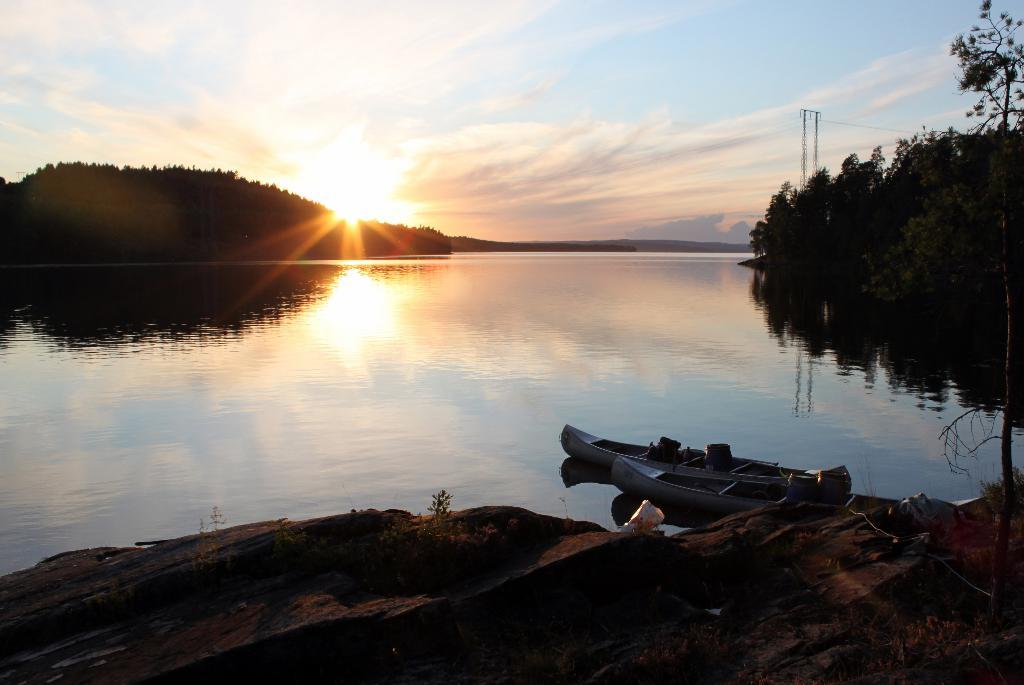What is one of the main elements in the image? There is water in the image. What other objects can be seen in the water? There are boats in the image. What type of terrain is visible in the image? There are stones and mud in the image. Where are trees located in the image? Trees can be seen on the right side of the image and in the left side background of the image. What part of the natural environment is visible in the image? The sky is visible in the image. What type of wound can be seen on the boat in the image? There is no wound present on the boat in the image. What type of comfort can be seen in the image? There is no comfort or comforting action depicted in the image. 